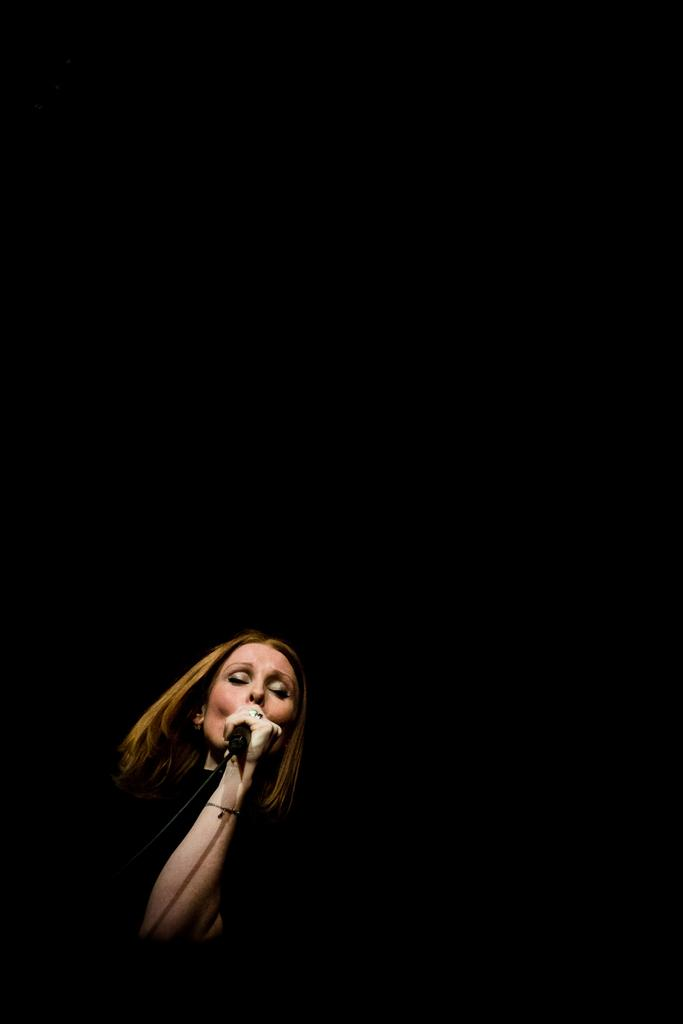Who is the main subject in the foreground of the image? There is a woman in the foreground of the image. What is the woman holding in the image? The woman is holding a microphone. What is the woman doing in the image? The woman is singing. How would you describe the lighting in the image? The background of the image is dark, and the top part of the image is also dark. What news is the woman reporting in the image? The image does not show the woman reporting news; she is singing with a microphone. Can you see a bucket in the image? There is no bucket present in the image. 